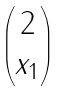<formula> <loc_0><loc_0><loc_500><loc_500>\begin{pmatrix} 2 \\ x _ { 1 } \end{pmatrix}</formula> 